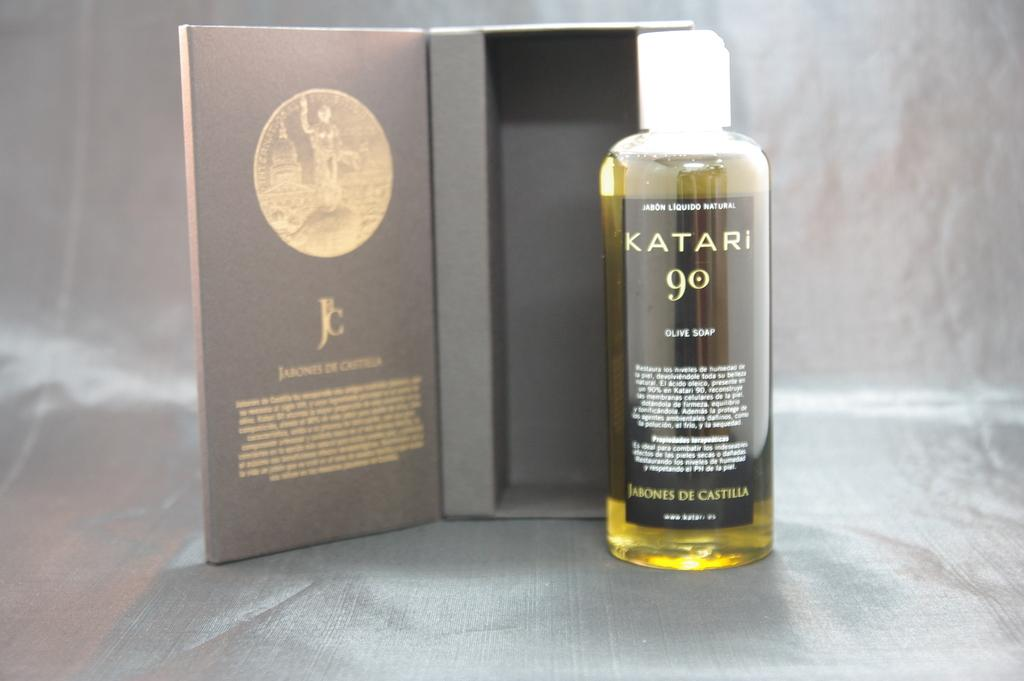<image>
Provide a brief description of the given image. A bottle of Katari 90 placed next to its case. 